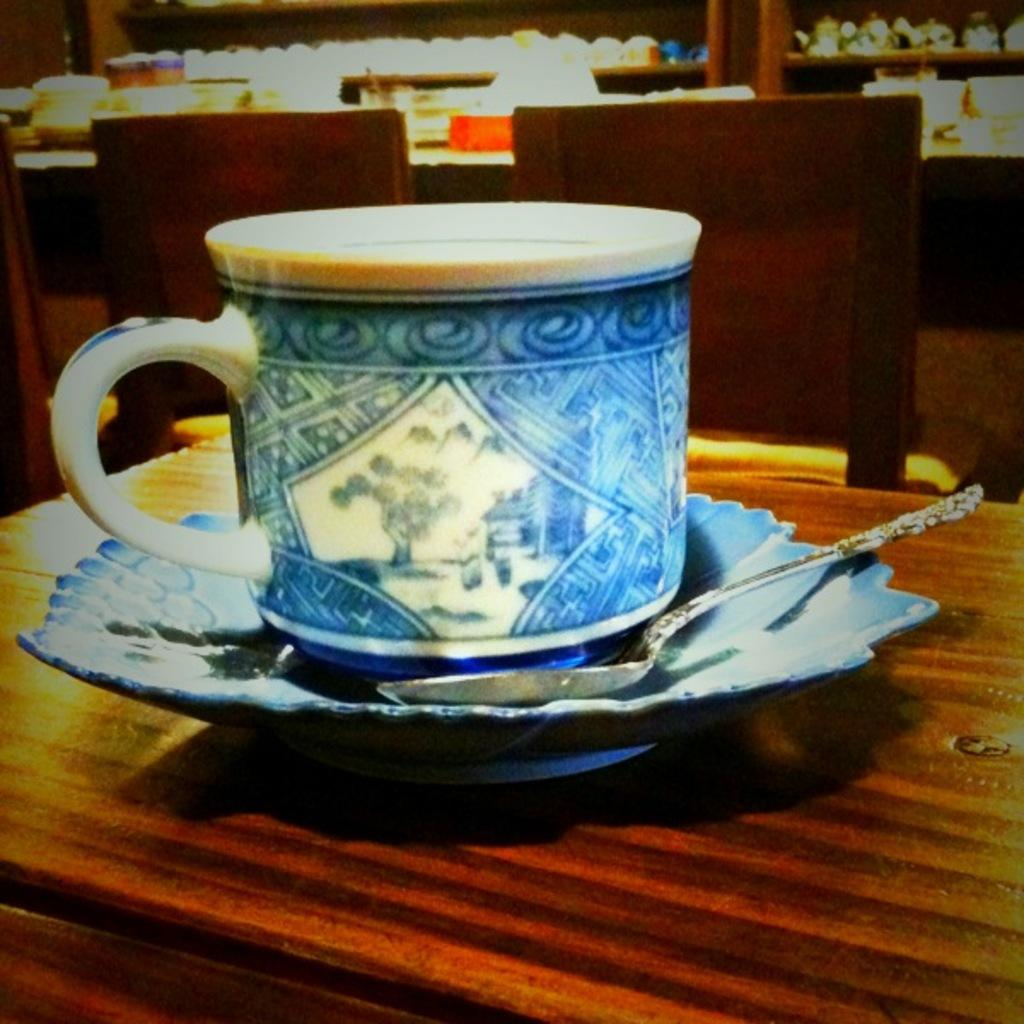What color is the cup in the image? The cup in the image is blue. What is the cup placed on? The cup is placed on a saucer. What utensil is present in the image? There is a spoon in the image. Where are the objects located? The objects are on a table. What can be seen in the background of the image? There is a chair and racks in the background of the image. What is on the racks in the background? There is a tea pot on the racks in the background of the image. What direction is the bell ringing in the image? There is no bell present in the image. What type of vest is the person wearing in the image? There are no people or vests present in the image. 